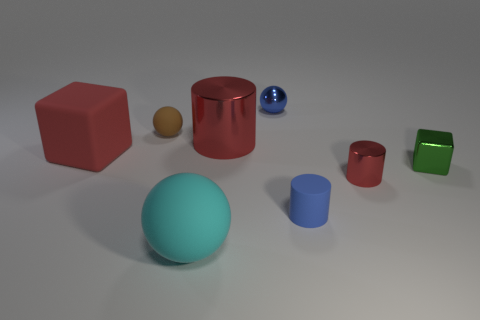Add 2 small things. How many objects exist? 10 Subtract all balls. How many objects are left? 5 Add 8 small brown rubber things. How many small brown rubber things exist? 9 Subtract 0 gray balls. How many objects are left? 8 Subtract all red shiny blocks. Subtract all tiny red shiny objects. How many objects are left? 7 Add 1 big metal things. How many big metal things are left? 2 